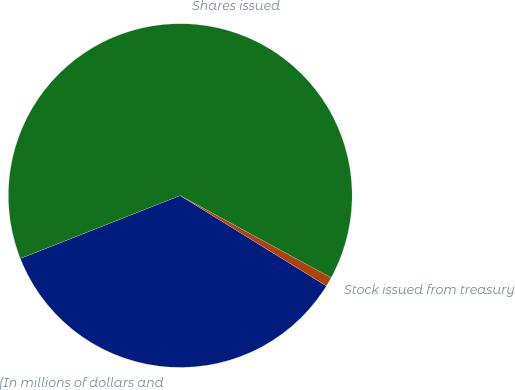Convert chart. <chart><loc_0><loc_0><loc_500><loc_500><pie_chart><fcel>(In millions of dollars and<fcel>Stock issued from treasury<fcel>Shares issued<nl><fcel>35.22%<fcel>0.88%<fcel>63.9%<nl></chart> 